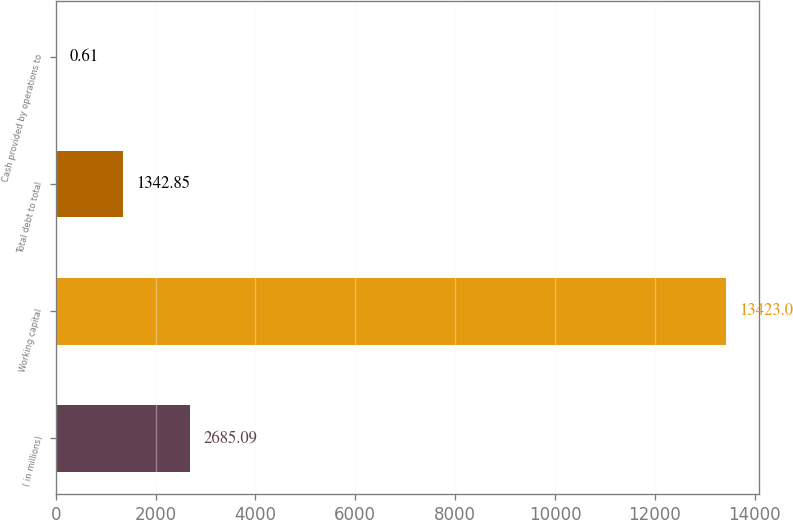Convert chart. <chart><loc_0><loc_0><loc_500><loc_500><bar_chart><fcel>( in millions)<fcel>Working capital<fcel>Total debt to total<fcel>Cash provided by operations to<nl><fcel>2685.09<fcel>13423<fcel>1342.85<fcel>0.61<nl></chart> 